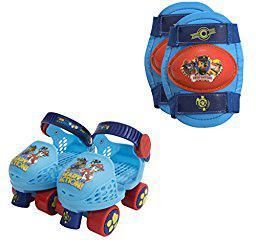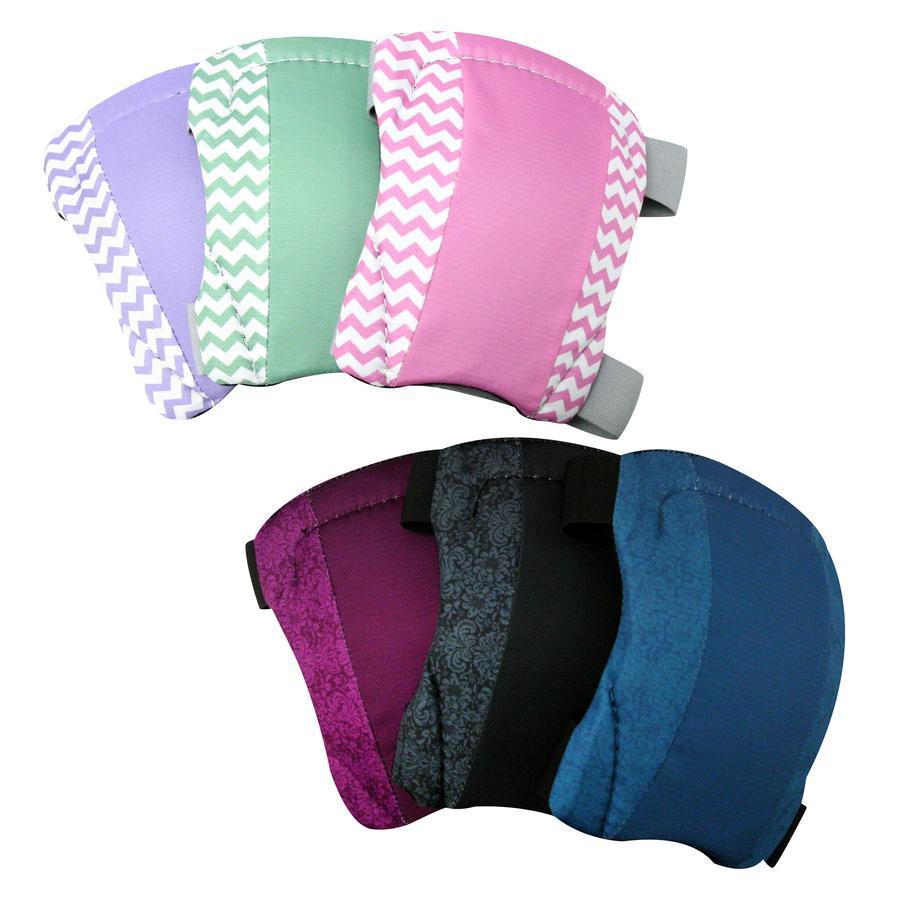The first image is the image on the left, the second image is the image on the right. For the images shown, is this caption "One image contains exactly two roller skates and two pads." true? Answer yes or no. Yes. The first image is the image on the left, the second image is the image on the right. Evaluate the accuracy of this statement regarding the images: "All images have both knee pads and gloves.". Is it true? Answer yes or no. No. 